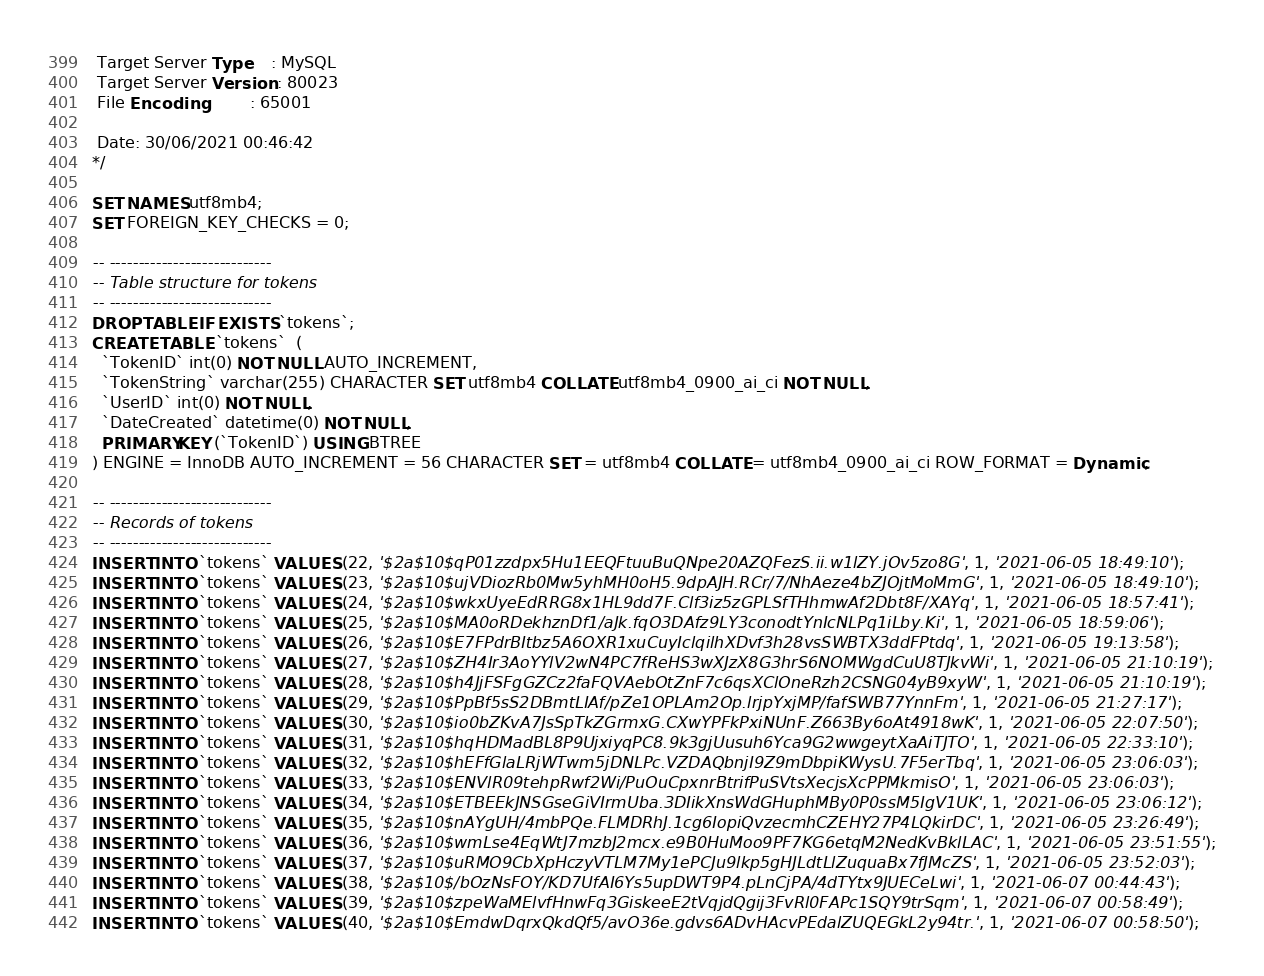<code> <loc_0><loc_0><loc_500><loc_500><_SQL_>
 Target Server Type    : MySQL
 Target Server Version : 80023
 File Encoding         : 65001

 Date: 30/06/2021 00:46:42
*/

SET NAMES utf8mb4;
SET FOREIGN_KEY_CHECKS = 0;

-- ----------------------------
-- Table structure for tokens
-- ----------------------------
DROP TABLE IF EXISTS `tokens`;
CREATE TABLE `tokens`  (
  `TokenID` int(0) NOT NULL AUTO_INCREMENT,
  `TokenString` varchar(255) CHARACTER SET utf8mb4 COLLATE utf8mb4_0900_ai_ci NOT NULL,
  `UserID` int(0) NOT NULL,
  `DateCreated` datetime(0) NOT NULL,
  PRIMARY KEY (`TokenID`) USING BTREE
) ENGINE = InnoDB AUTO_INCREMENT = 56 CHARACTER SET = utf8mb4 COLLATE = utf8mb4_0900_ai_ci ROW_FORMAT = Dynamic;

-- ----------------------------
-- Records of tokens
-- ----------------------------
INSERT INTO `tokens` VALUES (22, '$2a$10$qP01zzdpx5Hu1EEQFtuuBuQNpe20AZQFezS.ii.w1lZY.jOv5zo8G', 1, '2021-06-05 18:49:10');
INSERT INTO `tokens` VALUES (23, '$2a$10$ujVDiozRb0Mw5yhMH0oH5.9dpAJH.RCr/7/NhAeze4bZJOjtMoMmG', 1, '2021-06-05 18:49:10');
INSERT INTO `tokens` VALUES (24, '$2a$10$wkxUyeEdRRG8x1HL9dd7F.Clf3iz5zGPLSfTHhmwAf2Dbt8F/XAYq', 1, '2021-06-05 18:57:41');
INSERT INTO `tokens` VALUES (25, '$2a$10$MA0oRDekhznDf1/aJk.fqO3DAfz9LY3conodtYnIcNLPq1iLby.Ki', 1, '2021-06-05 18:59:06');
INSERT INTO `tokens` VALUES (26, '$2a$10$E7FPdrBItbz5A6OXR1xuCuyIclqilhXDvf3h28vsSWBTX3ddFPtdq', 1, '2021-06-05 19:13:58');
INSERT INTO `tokens` VALUES (27, '$2a$10$ZH4Ir3AoYYlV2wN4PC7fReHS3wXJzX8G3hrS6NOMWgdCuU8TJkvWi', 1, '2021-06-05 21:10:19');
INSERT INTO `tokens` VALUES (28, '$2a$10$h4JjFSFgGZCz2faFQVAebOtZnF7c6qsXClOneRzh2CSNG04yB9xyW', 1, '2021-06-05 21:10:19');
INSERT INTO `tokens` VALUES (29, '$2a$10$PpBf5sS2DBmtLIAf/pZe1OPLAm2Op.lrjpYxjMP/fafSWB77YnnFm', 1, '2021-06-05 21:27:17');
INSERT INTO `tokens` VALUES (30, '$2a$10$io0bZKvA7JsSpTkZGrmxG.CXwYPFkPxiNUnF.Z663By6oAt4918wK', 1, '2021-06-05 22:07:50');
INSERT INTO `tokens` VALUES (31, '$2a$10$hqHDMadBL8P9UjxiyqPC8.9k3gjUusuh6Yca9G2wwgeytXaAiTJTO', 1, '2021-06-05 22:33:10');
INSERT INTO `tokens` VALUES (32, '$2a$10$hEFfGlaLRjWTwm5jDNLPc.VZDAQbnjI9Z9mDbpiKWysU.7F5erTbq', 1, '2021-06-05 23:06:03');
INSERT INTO `tokens` VALUES (33, '$2a$10$ENVlR09tehpRwf2Wi/PuOuCpxnrBtrifPuSVtsXecjsXcPPMkmisO', 1, '2021-06-05 23:06:03');
INSERT INTO `tokens` VALUES (34, '$2a$10$ETBEEkJNSGseGiVIrmUba.3DIikXnsWdGHuphMBy0P0ssM5IgV1UK', 1, '2021-06-05 23:06:12');
INSERT INTO `tokens` VALUES (35, '$2a$10$nAYgUH/4mbPQe.FLMDRhJ.1cg6IopiQvzecmhCZEHY27P4LQkirDC', 1, '2021-06-05 23:26:49');
INSERT INTO `tokens` VALUES (36, '$2a$10$wmLse4EqWtJ7mzbJ2mcx.e9B0HuMoo9PF7KG6etqM2NedKvBklLAC', 1, '2021-06-05 23:51:55');
INSERT INTO `tokens` VALUES (37, '$2a$10$uRMO9CbXpHczyVTLM7My1ePCJu9lkp5gHJLdtLlZuquaBx7fJMcZS', 1, '2021-06-05 23:52:03');
INSERT INTO `tokens` VALUES (38, '$2a$10$/bOzNsFOY/KD7UfAI6Ys5upDWT9P4.pLnCjPA/4dTYtx9JUECeLwi', 1, '2021-06-07 00:44:43');
INSERT INTO `tokens` VALUES (39, '$2a$10$zpeWaMElvfHnwFq3GiskeeE2tVqjdQgij3FvRl0FAPc1SQY9trSqm', 1, '2021-06-07 00:58:49');
INSERT INTO `tokens` VALUES (40, '$2a$10$EmdwDqrxQkdQf5/avO36e.gdvs6ADvHAcvPEdalZUQEGkL2y94tr.', 1, '2021-06-07 00:58:50');</code> 